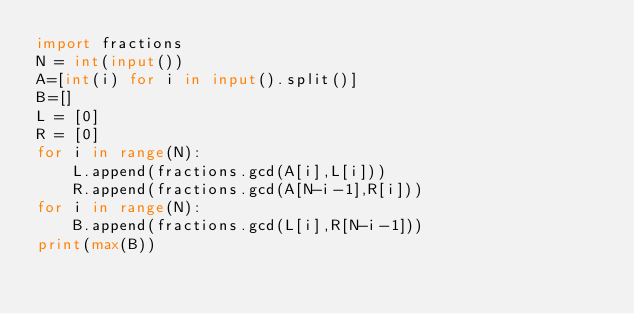Convert code to text. <code><loc_0><loc_0><loc_500><loc_500><_Python_>import fractions
N = int(input())
A=[int(i) for i in input().split()]
B=[]
L = [0]
R = [0]
for i in range(N):
    L.append(fractions.gcd(A[i],L[i]))
    R.append(fractions.gcd(A[N-i-1],R[i]))
for i in range(N):
    B.append(fractions.gcd(L[i],R[N-i-1]))
print(max(B))</code> 